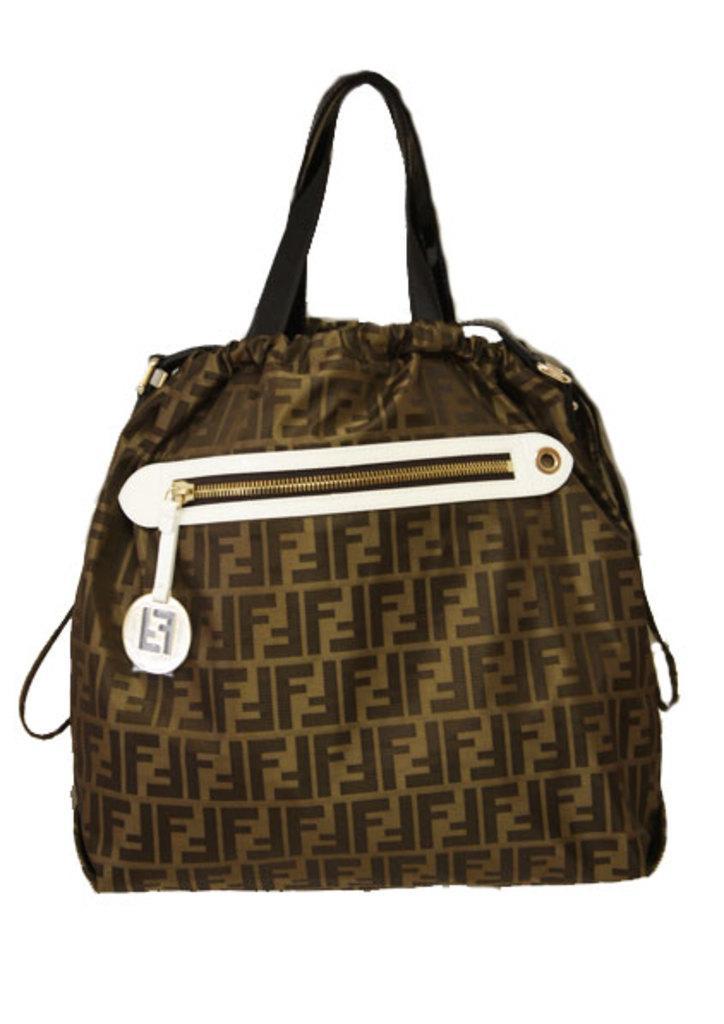Can you describe this image briefly? There is a beautiful brown and gold color hand bag which has a zip facility. To the zip there is also a label attached. The bag has a beautifully printed texture. 